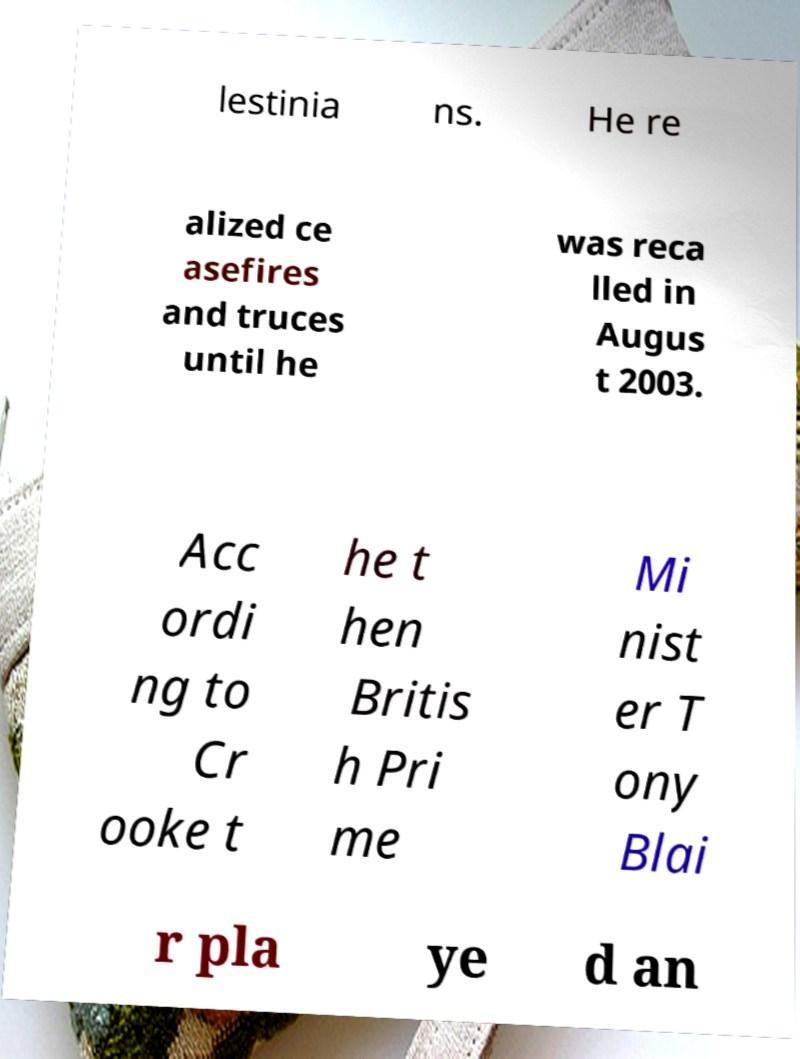Can you accurately transcribe the text from the provided image for me? lestinia ns. He re alized ce asefires and truces until he was reca lled in Augus t 2003. Acc ordi ng to Cr ooke t he t hen Britis h Pri me Mi nist er T ony Blai r pla ye d an 